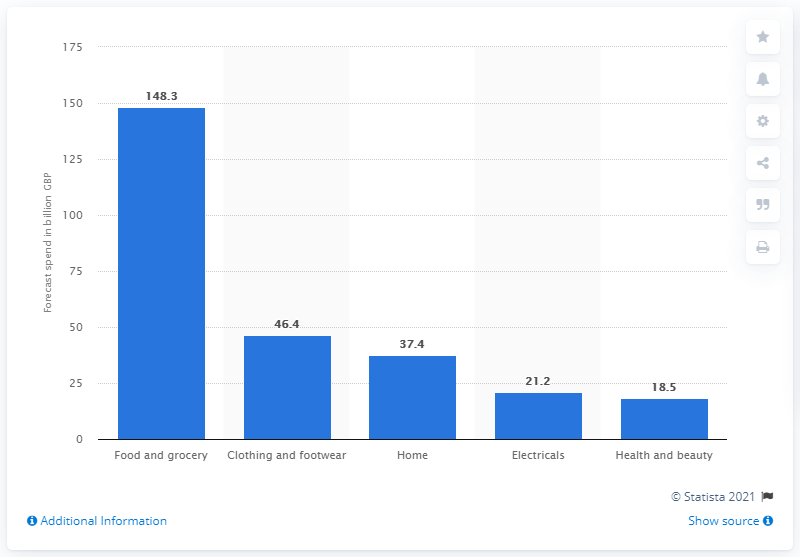Specify some key components in this picture. The estimated value of spending in the food and grocery market by the end of 2014 was 148.3 billion dollars. 